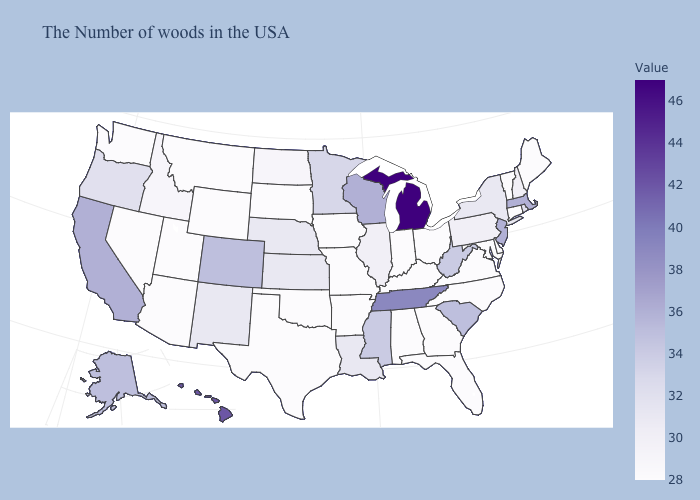Among the states that border Oklahoma , does Colorado have the highest value?
Be succinct. Yes. Which states have the lowest value in the South?
Concise answer only. Delaware, Maryland, Virginia, North Carolina, Florida, Georgia, Kentucky, Alabama, Arkansas, Oklahoma, Texas. Which states have the lowest value in the USA?
Short answer required. Maine, Vermont, Connecticut, Delaware, Maryland, Virginia, North Carolina, Ohio, Florida, Georgia, Kentucky, Indiana, Alabama, Missouri, Arkansas, Iowa, Oklahoma, Texas, South Dakota, Wyoming, Utah, Montana, Arizona, Nevada, Washington. Which states have the highest value in the USA?
Short answer required. Michigan. Does the map have missing data?
Keep it brief. No. Does Mississippi have a lower value than Alabama?
Give a very brief answer. No. Does Ohio have the lowest value in the MidWest?
Be succinct. Yes. Does Pennsylvania have the lowest value in the USA?
Be succinct. No. 